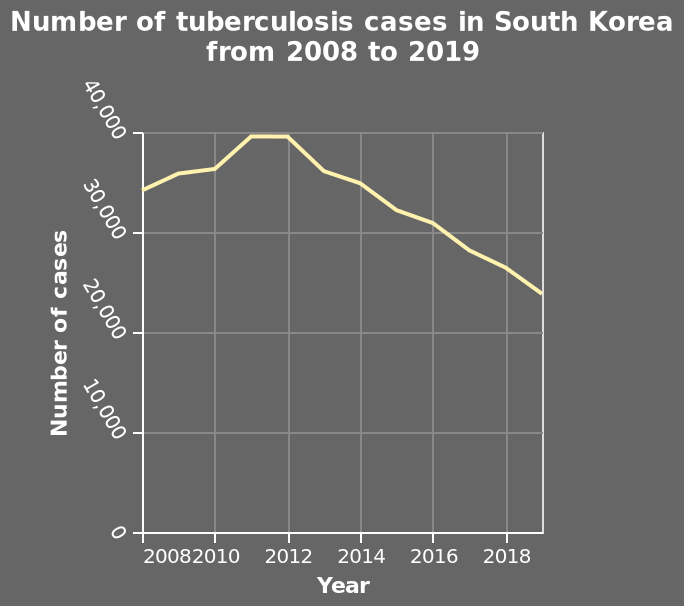<image>
What is the highest number of tuberculosis cases recorded during the given period? The line chart does not provide information about the highest number of tuberculosis cases. How many cases of tuberculosis were reported in 2011 and 2019 respectively? The number of tuberculosis cases reported in 2011 was the highest, while the lowest number of cases was reported in 2019. What does the x-axis represent in the line chart?  The x-axis represents the years from 2008 to 2019. 